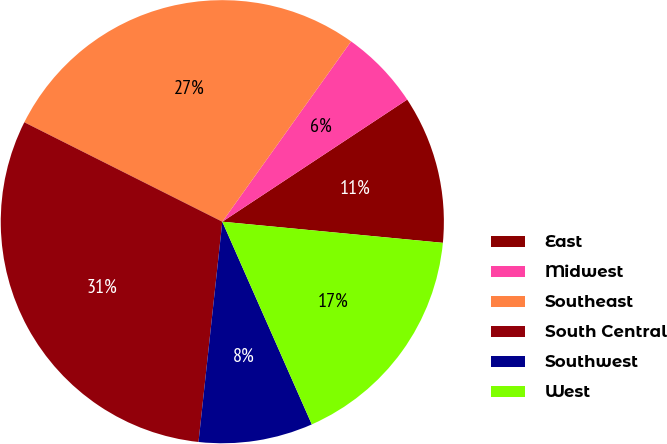Convert chart to OTSL. <chart><loc_0><loc_0><loc_500><loc_500><pie_chart><fcel>East<fcel>Midwest<fcel>Southeast<fcel>South Central<fcel>Southwest<fcel>West<nl><fcel>10.81%<fcel>5.84%<fcel>27.46%<fcel>30.69%<fcel>8.33%<fcel>16.86%<nl></chart> 